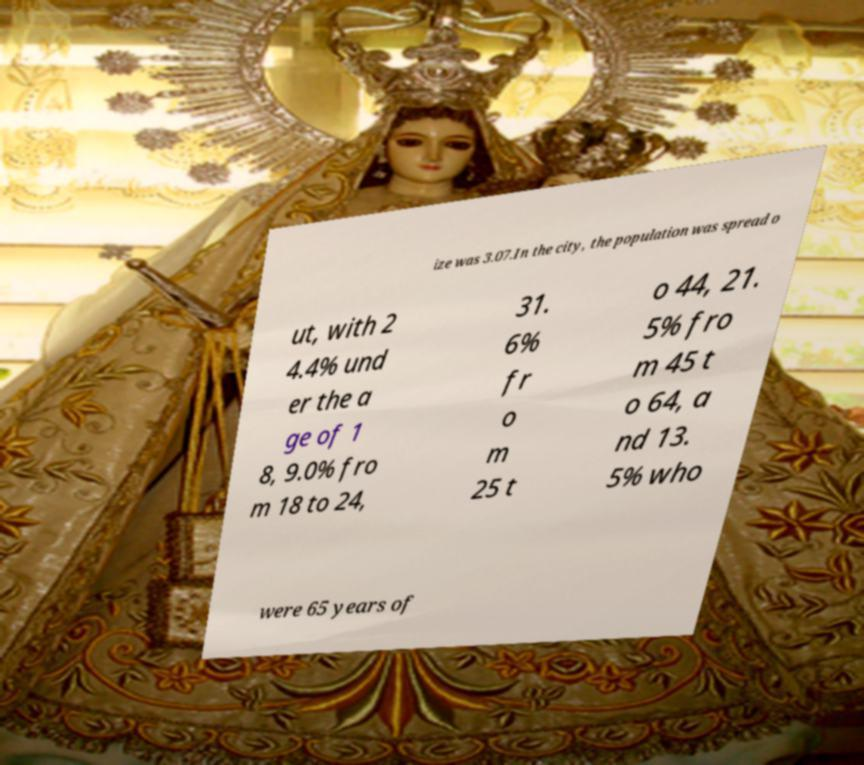Can you read and provide the text displayed in the image?This photo seems to have some interesting text. Can you extract and type it out for me? ize was 3.07.In the city, the population was spread o ut, with 2 4.4% und er the a ge of 1 8, 9.0% fro m 18 to 24, 31. 6% fr o m 25 t o 44, 21. 5% fro m 45 t o 64, a nd 13. 5% who were 65 years of 